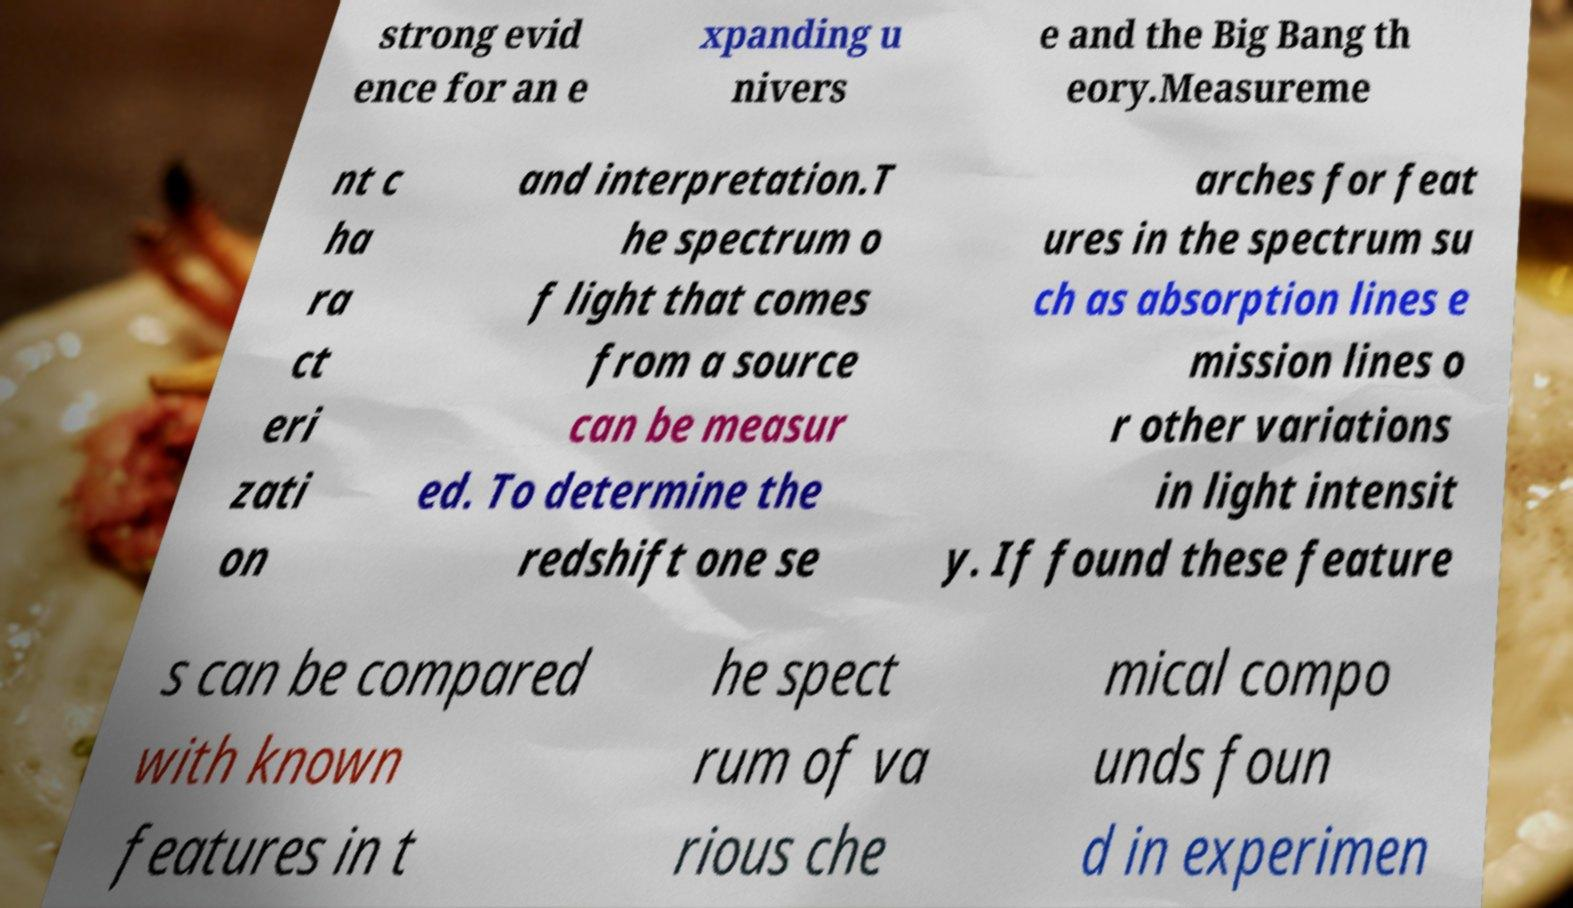Please read and relay the text visible in this image. What does it say? strong evid ence for an e xpanding u nivers e and the Big Bang th eory.Measureme nt c ha ra ct eri zati on and interpretation.T he spectrum o f light that comes from a source can be measur ed. To determine the redshift one se arches for feat ures in the spectrum su ch as absorption lines e mission lines o r other variations in light intensit y. If found these feature s can be compared with known features in t he spect rum of va rious che mical compo unds foun d in experimen 